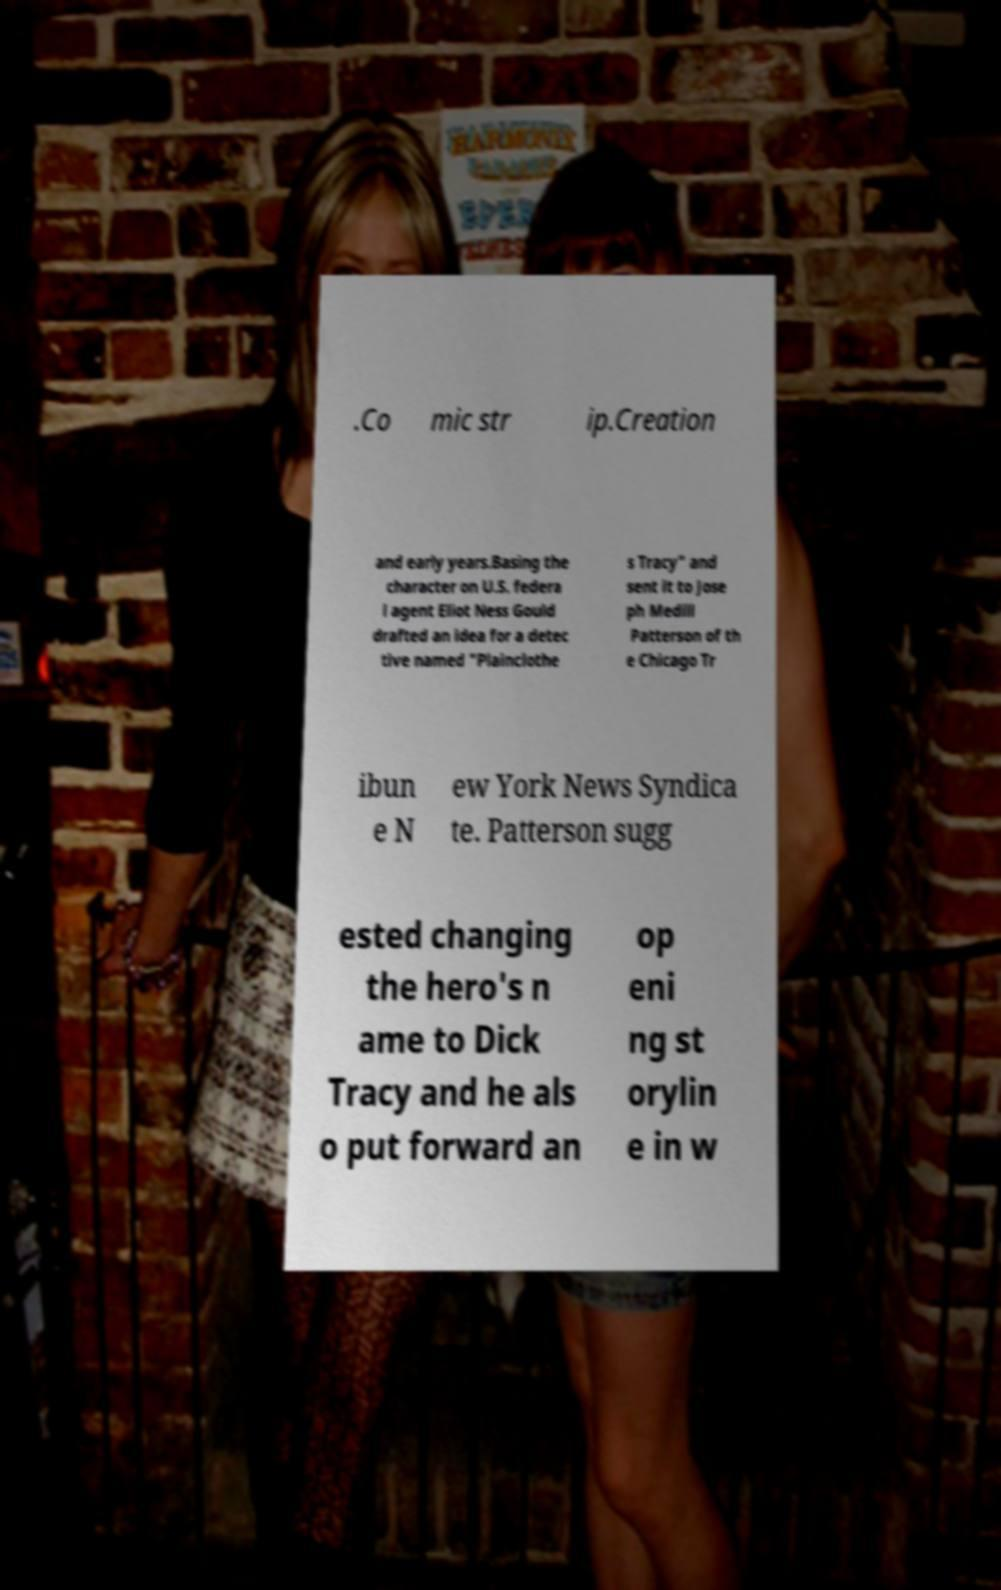I need the written content from this picture converted into text. Can you do that? .Co mic str ip.Creation and early years.Basing the character on U.S. federa l agent Eliot Ness Gould drafted an idea for a detec tive named "Plainclothe s Tracy" and sent it to Jose ph Medill Patterson of th e Chicago Tr ibun e N ew York News Syndica te. Patterson sugg ested changing the hero's n ame to Dick Tracy and he als o put forward an op eni ng st orylin e in w 